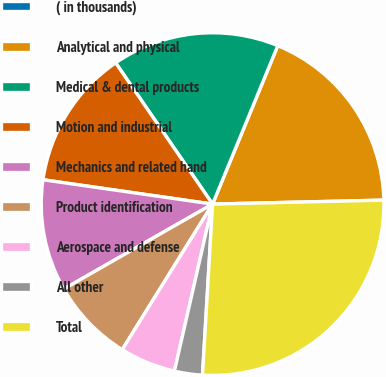Convert chart to OTSL. <chart><loc_0><loc_0><loc_500><loc_500><pie_chart><fcel>( in thousands)<fcel>Analytical and physical<fcel>Medical & dental products<fcel>Motion and industrial<fcel>Mechanics and related hand<fcel>Product identification<fcel>Aerospace and defense<fcel>All other<fcel>Total<nl><fcel>0.0%<fcel>18.42%<fcel>15.79%<fcel>13.16%<fcel>10.53%<fcel>7.9%<fcel>5.27%<fcel>2.64%<fcel>26.31%<nl></chart> 